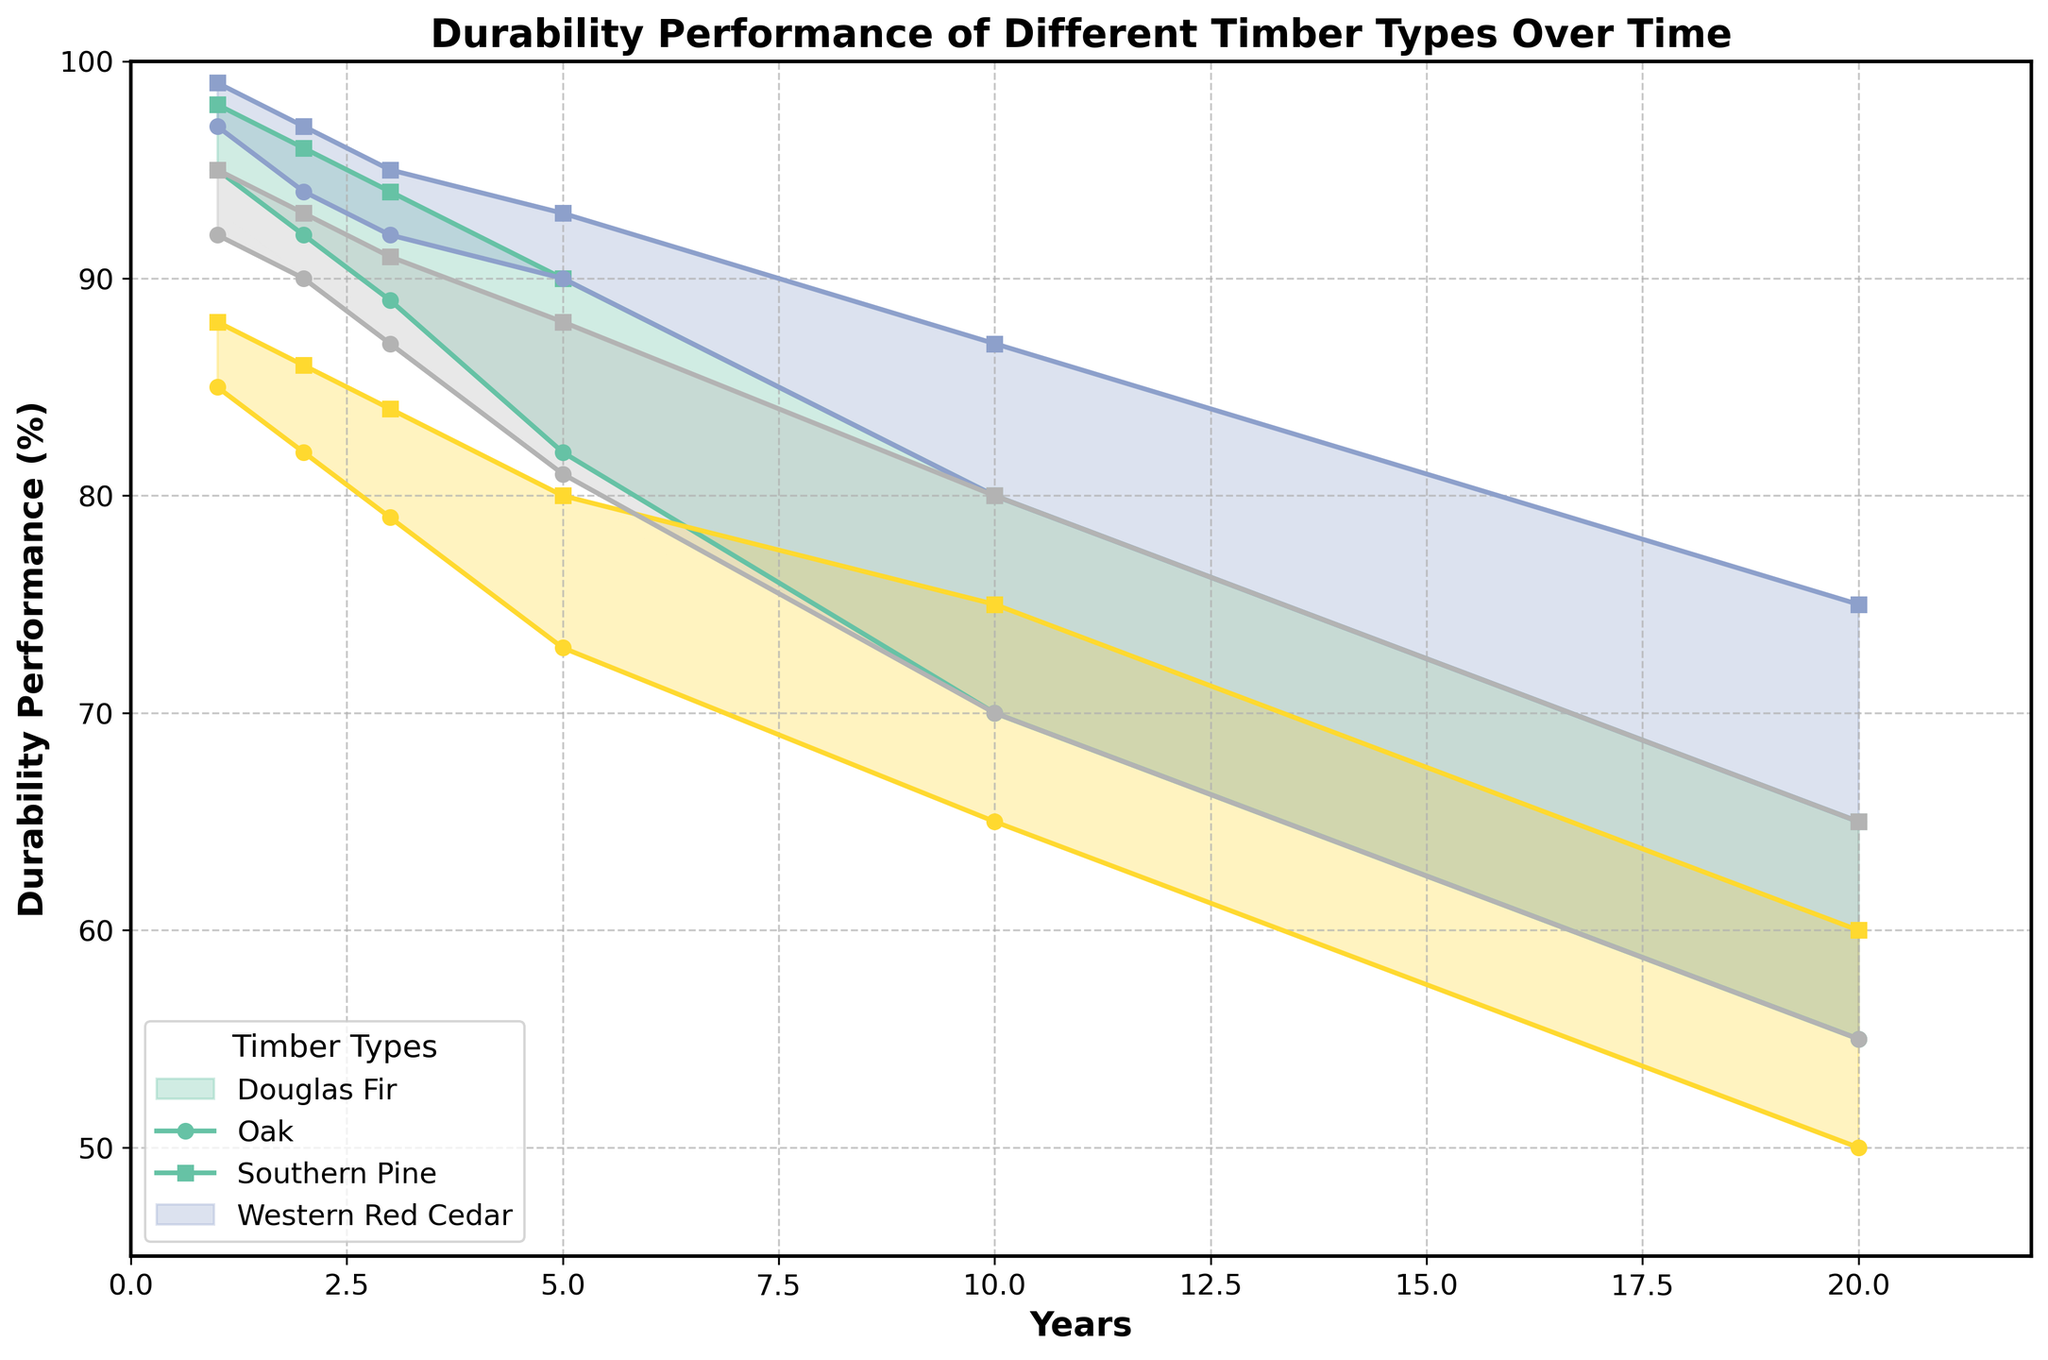Which timber type shows the highest maximum durability in the first year? Examine the figure and identify the timber type that reaches the highest point on the graph in the first year on the x-axis. The highest point is shared between Oak and Douglas Fir at around 99% and 98%, respectively.
Answer: Oak Which timber type shows the largest range of durability performance in the 10th year? To find this, compare the difference between the maximum and minimum durability values for each timber type in the 10th year. The largest range is in Southern Pine, which shows a spread from 65% to 75%, giving a 10% range.
Answer: Southern Pine How does the durability of Douglas Fir change from the 1st year to the 5th year? Check the durability values for Douglas Fir at the 1st and 5th years. In the 1st year, it ranges from 95% to 98%, and in the 5th year, it ranges from 82% to 90%. The maximum and minimum durability both decrease over time.
Answer: Decreases Which timber type has the least amount of decrease in minimum durability over 20 years? For each timber type, compute the decrease in minimum durability from the 1st year to the 20th year. The least decrease is shown by Oak, which drops from 97% to 65%, a decrease of 32%.
Answer: Oak Which two timber types have the same minimum durability in the 20th year? Look at the minimum durability values in the 20th year. Both Douglas Fir and Western Red Cedar have a minimum durability of 55%.
Answer: Douglas Fir and Western Red Cedar Is there any timber type whose durability does not fall below 80% over the 20 years? Examine the minimum durability line for all timber types and see if any remain above 80%. No timber type does; all fall below 80% over the 20 years.
Answer: No What's the difference in maximum durability between Oak and Southern Pine in the 5th year? Compare the maximum durability values of Oak and Southern Pine in the 5th year. Oak’s maximum is 93%, and Southern Pine’s is 80%. The difference is 93% - 80% = 13%.
Answer: 13% Which timber type maintains the highest minimum durability across all years? Compare the minimum durability values for all timber types for each year and identify which timber type consistently has the highest minimum durability. Oak has the highest minimum durability across all years.
Answer: Oak By how much does the maximum durability of Western Red Cedar decrease from the 3rd year to the 10th year? Determine the maximum durability of Western Red Cedar in the 3rd year (91%) and the 10th year (80%). The decrease is 91% - 80% = 11%.
Answer: 11% 